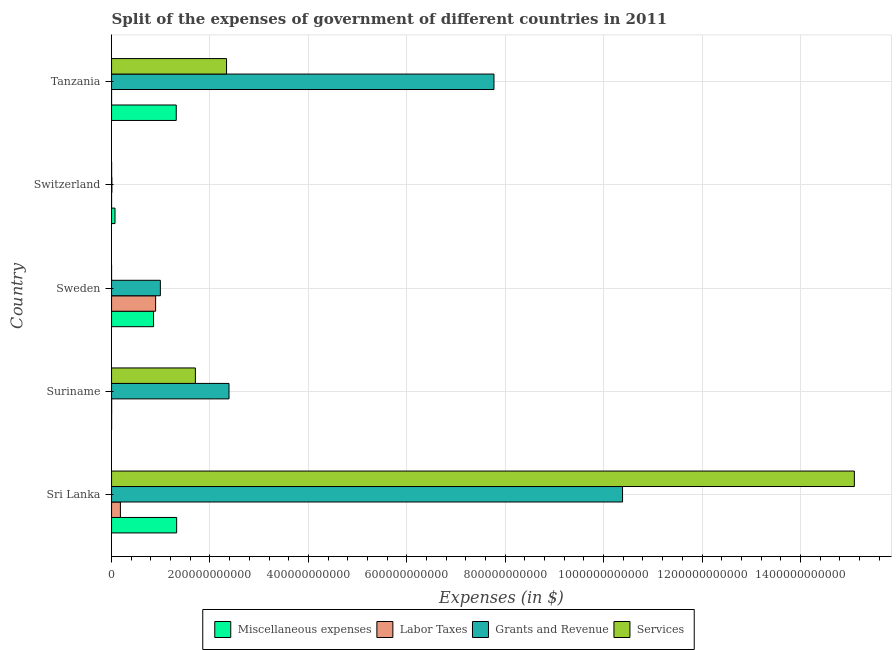How many groups of bars are there?
Your answer should be compact. 5. Are the number of bars per tick equal to the number of legend labels?
Keep it short and to the point. Yes. How many bars are there on the 5th tick from the bottom?
Keep it short and to the point. 4. What is the label of the 1st group of bars from the top?
Offer a terse response. Tanzania. In how many cases, is the number of bars for a given country not equal to the number of legend labels?
Provide a short and direct response. 0. What is the amount spent on grants and revenue in Sweden?
Your response must be concise. 9.92e+1. Across all countries, what is the maximum amount spent on labor taxes?
Your response must be concise. 8.96e+1. Across all countries, what is the minimum amount spent on services?
Ensure brevity in your answer.  1.13e+05. In which country was the amount spent on services maximum?
Provide a short and direct response. Sri Lanka. In which country was the amount spent on grants and revenue minimum?
Your answer should be very brief. Switzerland. What is the total amount spent on services in the graph?
Your answer should be very brief. 1.91e+12. What is the difference between the amount spent on labor taxes in Sweden and that in Tanzania?
Make the answer very short. 8.96e+1. What is the difference between the amount spent on miscellaneous expenses in Sweden and the amount spent on grants and revenue in Switzerland?
Keep it short and to the point. 8.47e+1. What is the average amount spent on grants and revenue per country?
Provide a succinct answer. 4.31e+11. What is the difference between the amount spent on services and amount spent on labor taxes in Tanzania?
Provide a short and direct response. 2.34e+11. What is the ratio of the amount spent on miscellaneous expenses in Sweden to that in Tanzania?
Your answer should be compact. 0.65. Is the amount spent on labor taxes in Switzerland less than that in Tanzania?
Offer a very short reply. No. Is the difference between the amount spent on services in Switzerland and Tanzania greater than the difference between the amount spent on grants and revenue in Switzerland and Tanzania?
Give a very brief answer. Yes. What is the difference between the highest and the second highest amount spent on miscellaneous expenses?
Make the answer very short. 8.34e+08. What is the difference between the highest and the lowest amount spent on grants and revenue?
Your answer should be very brief. 1.04e+12. Is it the case that in every country, the sum of the amount spent on miscellaneous expenses and amount spent on labor taxes is greater than the sum of amount spent on grants and revenue and amount spent on services?
Provide a succinct answer. No. What does the 1st bar from the top in Sri Lanka represents?
Offer a very short reply. Services. What does the 2nd bar from the bottom in Sri Lanka represents?
Your answer should be compact. Labor Taxes. How many bars are there?
Make the answer very short. 20. What is the difference between two consecutive major ticks on the X-axis?
Keep it short and to the point. 2.00e+11. Does the graph contain grids?
Offer a terse response. Yes. How are the legend labels stacked?
Offer a terse response. Horizontal. What is the title of the graph?
Offer a terse response. Split of the expenses of government of different countries in 2011. What is the label or title of the X-axis?
Ensure brevity in your answer.  Expenses (in $). What is the Expenses (in $) of Miscellaneous expenses in Sri Lanka?
Your answer should be very brief. 1.32e+11. What is the Expenses (in $) in Labor Taxes in Sri Lanka?
Provide a short and direct response. 1.80e+1. What is the Expenses (in $) in Grants and Revenue in Sri Lanka?
Provide a short and direct response. 1.04e+12. What is the Expenses (in $) of Services in Sri Lanka?
Keep it short and to the point. 1.51e+12. What is the Expenses (in $) in Miscellaneous expenses in Suriname?
Provide a succinct answer. 1.15e+08. What is the Expenses (in $) in Labor Taxes in Suriname?
Offer a very short reply. 2.01e+08. What is the Expenses (in $) of Grants and Revenue in Suriname?
Provide a succinct answer. 2.39e+11. What is the Expenses (in $) in Services in Suriname?
Your answer should be very brief. 1.70e+11. What is the Expenses (in $) in Miscellaneous expenses in Sweden?
Your answer should be very brief. 8.53e+1. What is the Expenses (in $) of Labor Taxes in Sweden?
Provide a short and direct response. 8.96e+1. What is the Expenses (in $) of Grants and Revenue in Sweden?
Your answer should be very brief. 9.92e+1. What is the Expenses (in $) in Services in Sweden?
Ensure brevity in your answer.  1.13e+05. What is the Expenses (in $) of Miscellaneous expenses in Switzerland?
Ensure brevity in your answer.  6.99e+09. What is the Expenses (in $) of Labor Taxes in Switzerland?
Give a very brief answer. 8.80e+06. What is the Expenses (in $) in Grants and Revenue in Switzerland?
Your answer should be compact. 6.70e+08. What is the Expenses (in $) in Services in Switzerland?
Your answer should be very brief. 1.39e+08. What is the Expenses (in $) in Miscellaneous expenses in Tanzania?
Give a very brief answer. 1.31e+11. What is the Expenses (in $) of Grants and Revenue in Tanzania?
Keep it short and to the point. 7.77e+11. What is the Expenses (in $) of Services in Tanzania?
Make the answer very short. 2.34e+11. Across all countries, what is the maximum Expenses (in $) in Miscellaneous expenses?
Give a very brief answer. 1.32e+11. Across all countries, what is the maximum Expenses (in $) in Labor Taxes?
Provide a succinct answer. 8.96e+1. Across all countries, what is the maximum Expenses (in $) in Grants and Revenue?
Give a very brief answer. 1.04e+12. Across all countries, what is the maximum Expenses (in $) in Services?
Offer a terse response. 1.51e+12. Across all countries, what is the minimum Expenses (in $) in Miscellaneous expenses?
Provide a short and direct response. 1.15e+08. Across all countries, what is the minimum Expenses (in $) in Grants and Revenue?
Your response must be concise. 6.70e+08. Across all countries, what is the minimum Expenses (in $) in Services?
Your answer should be compact. 1.13e+05. What is the total Expenses (in $) of Miscellaneous expenses in the graph?
Your response must be concise. 3.56e+11. What is the total Expenses (in $) in Labor Taxes in the graph?
Your response must be concise. 1.08e+11. What is the total Expenses (in $) of Grants and Revenue in the graph?
Provide a succinct answer. 2.15e+12. What is the total Expenses (in $) of Services in the graph?
Your answer should be very brief. 1.91e+12. What is the difference between the Expenses (in $) of Miscellaneous expenses in Sri Lanka and that in Suriname?
Offer a very short reply. 1.32e+11. What is the difference between the Expenses (in $) in Labor Taxes in Sri Lanka and that in Suriname?
Your answer should be very brief. 1.78e+1. What is the difference between the Expenses (in $) of Grants and Revenue in Sri Lanka and that in Suriname?
Provide a succinct answer. 8.00e+11. What is the difference between the Expenses (in $) of Services in Sri Lanka and that in Suriname?
Provide a short and direct response. 1.34e+12. What is the difference between the Expenses (in $) of Miscellaneous expenses in Sri Lanka and that in Sweden?
Ensure brevity in your answer.  4.70e+1. What is the difference between the Expenses (in $) of Labor Taxes in Sri Lanka and that in Sweden?
Offer a terse response. -7.16e+1. What is the difference between the Expenses (in $) in Grants and Revenue in Sri Lanka and that in Sweden?
Keep it short and to the point. 9.39e+11. What is the difference between the Expenses (in $) in Services in Sri Lanka and that in Sweden?
Make the answer very short. 1.51e+12. What is the difference between the Expenses (in $) of Miscellaneous expenses in Sri Lanka and that in Switzerland?
Keep it short and to the point. 1.25e+11. What is the difference between the Expenses (in $) in Labor Taxes in Sri Lanka and that in Switzerland?
Your answer should be compact. 1.80e+1. What is the difference between the Expenses (in $) in Grants and Revenue in Sri Lanka and that in Switzerland?
Your answer should be very brief. 1.04e+12. What is the difference between the Expenses (in $) of Services in Sri Lanka and that in Switzerland?
Ensure brevity in your answer.  1.51e+12. What is the difference between the Expenses (in $) in Miscellaneous expenses in Sri Lanka and that in Tanzania?
Ensure brevity in your answer.  8.34e+08. What is the difference between the Expenses (in $) of Labor Taxes in Sri Lanka and that in Tanzania?
Offer a terse response. 1.80e+1. What is the difference between the Expenses (in $) in Grants and Revenue in Sri Lanka and that in Tanzania?
Your response must be concise. 2.61e+11. What is the difference between the Expenses (in $) in Services in Sri Lanka and that in Tanzania?
Provide a succinct answer. 1.28e+12. What is the difference between the Expenses (in $) in Miscellaneous expenses in Suriname and that in Sweden?
Your response must be concise. -8.52e+1. What is the difference between the Expenses (in $) of Labor Taxes in Suriname and that in Sweden?
Provide a succinct answer. -8.94e+1. What is the difference between the Expenses (in $) of Grants and Revenue in Suriname and that in Sweden?
Offer a terse response. 1.40e+11. What is the difference between the Expenses (in $) in Services in Suriname and that in Sweden?
Offer a terse response. 1.70e+11. What is the difference between the Expenses (in $) of Miscellaneous expenses in Suriname and that in Switzerland?
Make the answer very short. -6.88e+09. What is the difference between the Expenses (in $) in Labor Taxes in Suriname and that in Switzerland?
Provide a succinct answer. 1.92e+08. What is the difference between the Expenses (in $) in Grants and Revenue in Suriname and that in Switzerland?
Provide a short and direct response. 2.38e+11. What is the difference between the Expenses (in $) in Services in Suriname and that in Switzerland?
Your answer should be very brief. 1.70e+11. What is the difference between the Expenses (in $) in Miscellaneous expenses in Suriname and that in Tanzania?
Your response must be concise. -1.31e+11. What is the difference between the Expenses (in $) in Labor Taxes in Suriname and that in Tanzania?
Your answer should be compact. 1.97e+08. What is the difference between the Expenses (in $) in Grants and Revenue in Suriname and that in Tanzania?
Ensure brevity in your answer.  -5.38e+11. What is the difference between the Expenses (in $) of Services in Suriname and that in Tanzania?
Your answer should be very brief. -6.33e+1. What is the difference between the Expenses (in $) in Miscellaneous expenses in Sweden and that in Switzerland?
Your answer should be compact. 7.83e+1. What is the difference between the Expenses (in $) of Labor Taxes in Sweden and that in Switzerland?
Your response must be concise. 8.95e+1. What is the difference between the Expenses (in $) in Grants and Revenue in Sweden and that in Switzerland?
Your answer should be compact. 9.85e+1. What is the difference between the Expenses (in $) in Services in Sweden and that in Switzerland?
Offer a terse response. -1.39e+08. What is the difference between the Expenses (in $) in Miscellaneous expenses in Sweden and that in Tanzania?
Make the answer very short. -4.61e+1. What is the difference between the Expenses (in $) in Labor Taxes in Sweden and that in Tanzania?
Ensure brevity in your answer.  8.96e+1. What is the difference between the Expenses (in $) of Grants and Revenue in Sweden and that in Tanzania?
Provide a succinct answer. -6.78e+11. What is the difference between the Expenses (in $) in Services in Sweden and that in Tanzania?
Ensure brevity in your answer.  -2.34e+11. What is the difference between the Expenses (in $) in Miscellaneous expenses in Switzerland and that in Tanzania?
Provide a short and direct response. -1.24e+11. What is the difference between the Expenses (in $) in Labor Taxes in Switzerland and that in Tanzania?
Give a very brief answer. 4.80e+06. What is the difference between the Expenses (in $) of Grants and Revenue in Switzerland and that in Tanzania?
Give a very brief answer. -7.77e+11. What is the difference between the Expenses (in $) in Services in Switzerland and that in Tanzania?
Make the answer very short. -2.34e+11. What is the difference between the Expenses (in $) in Miscellaneous expenses in Sri Lanka and the Expenses (in $) in Labor Taxes in Suriname?
Provide a succinct answer. 1.32e+11. What is the difference between the Expenses (in $) of Miscellaneous expenses in Sri Lanka and the Expenses (in $) of Grants and Revenue in Suriname?
Your answer should be very brief. -1.06e+11. What is the difference between the Expenses (in $) of Miscellaneous expenses in Sri Lanka and the Expenses (in $) of Services in Suriname?
Ensure brevity in your answer.  -3.81e+1. What is the difference between the Expenses (in $) in Labor Taxes in Sri Lanka and the Expenses (in $) in Grants and Revenue in Suriname?
Keep it short and to the point. -2.21e+11. What is the difference between the Expenses (in $) of Labor Taxes in Sri Lanka and the Expenses (in $) of Services in Suriname?
Your response must be concise. -1.52e+11. What is the difference between the Expenses (in $) of Grants and Revenue in Sri Lanka and the Expenses (in $) of Services in Suriname?
Provide a short and direct response. 8.68e+11. What is the difference between the Expenses (in $) in Miscellaneous expenses in Sri Lanka and the Expenses (in $) in Labor Taxes in Sweden?
Your answer should be compact. 4.27e+1. What is the difference between the Expenses (in $) in Miscellaneous expenses in Sri Lanka and the Expenses (in $) in Grants and Revenue in Sweden?
Offer a terse response. 3.31e+1. What is the difference between the Expenses (in $) in Miscellaneous expenses in Sri Lanka and the Expenses (in $) in Services in Sweden?
Your answer should be compact. 1.32e+11. What is the difference between the Expenses (in $) in Labor Taxes in Sri Lanka and the Expenses (in $) in Grants and Revenue in Sweden?
Ensure brevity in your answer.  -8.12e+1. What is the difference between the Expenses (in $) of Labor Taxes in Sri Lanka and the Expenses (in $) of Services in Sweden?
Offer a very short reply. 1.80e+1. What is the difference between the Expenses (in $) of Grants and Revenue in Sri Lanka and the Expenses (in $) of Services in Sweden?
Give a very brief answer. 1.04e+12. What is the difference between the Expenses (in $) of Miscellaneous expenses in Sri Lanka and the Expenses (in $) of Labor Taxes in Switzerland?
Provide a succinct answer. 1.32e+11. What is the difference between the Expenses (in $) in Miscellaneous expenses in Sri Lanka and the Expenses (in $) in Grants and Revenue in Switzerland?
Give a very brief answer. 1.32e+11. What is the difference between the Expenses (in $) in Miscellaneous expenses in Sri Lanka and the Expenses (in $) in Services in Switzerland?
Your response must be concise. 1.32e+11. What is the difference between the Expenses (in $) in Labor Taxes in Sri Lanka and the Expenses (in $) in Grants and Revenue in Switzerland?
Make the answer very short. 1.73e+1. What is the difference between the Expenses (in $) in Labor Taxes in Sri Lanka and the Expenses (in $) in Services in Switzerland?
Ensure brevity in your answer.  1.79e+1. What is the difference between the Expenses (in $) of Grants and Revenue in Sri Lanka and the Expenses (in $) of Services in Switzerland?
Provide a succinct answer. 1.04e+12. What is the difference between the Expenses (in $) in Miscellaneous expenses in Sri Lanka and the Expenses (in $) in Labor Taxes in Tanzania?
Give a very brief answer. 1.32e+11. What is the difference between the Expenses (in $) in Miscellaneous expenses in Sri Lanka and the Expenses (in $) in Grants and Revenue in Tanzania?
Provide a succinct answer. -6.45e+11. What is the difference between the Expenses (in $) of Miscellaneous expenses in Sri Lanka and the Expenses (in $) of Services in Tanzania?
Keep it short and to the point. -1.01e+11. What is the difference between the Expenses (in $) of Labor Taxes in Sri Lanka and the Expenses (in $) of Grants and Revenue in Tanzania?
Provide a short and direct response. -7.59e+11. What is the difference between the Expenses (in $) in Labor Taxes in Sri Lanka and the Expenses (in $) in Services in Tanzania?
Your answer should be very brief. -2.16e+11. What is the difference between the Expenses (in $) of Grants and Revenue in Sri Lanka and the Expenses (in $) of Services in Tanzania?
Ensure brevity in your answer.  8.05e+11. What is the difference between the Expenses (in $) in Miscellaneous expenses in Suriname and the Expenses (in $) in Labor Taxes in Sweden?
Your answer should be very brief. -8.94e+1. What is the difference between the Expenses (in $) of Miscellaneous expenses in Suriname and the Expenses (in $) of Grants and Revenue in Sweden?
Provide a succinct answer. -9.91e+1. What is the difference between the Expenses (in $) in Miscellaneous expenses in Suriname and the Expenses (in $) in Services in Sweden?
Your answer should be very brief. 1.15e+08. What is the difference between the Expenses (in $) of Labor Taxes in Suriname and the Expenses (in $) of Grants and Revenue in Sweden?
Make the answer very short. -9.90e+1. What is the difference between the Expenses (in $) of Labor Taxes in Suriname and the Expenses (in $) of Services in Sweden?
Offer a terse response. 2.01e+08. What is the difference between the Expenses (in $) in Grants and Revenue in Suriname and the Expenses (in $) in Services in Sweden?
Your response must be concise. 2.39e+11. What is the difference between the Expenses (in $) of Miscellaneous expenses in Suriname and the Expenses (in $) of Labor Taxes in Switzerland?
Provide a succinct answer. 1.07e+08. What is the difference between the Expenses (in $) in Miscellaneous expenses in Suriname and the Expenses (in $) in Grants and Revenue in Switzerland?
Provide a short and direct response. -5.55e+08. What is the difference between the Expenses (in $) of Miscellaneous expenses in Suriname and the Expenses (in $) of Services in Switzerland?
Offer a very short reply. -2.40e+07. What is the difference between the Expenses (in $) of Labor Taxes in Suriname and the Expenses (in $) of Grants and Revenue in Switzerland?
Make the answer very short. -4.69e+08. What is the difference between the Expenses (in $) of Labor Taxes in Suriname and the Expenses (in $) of Services in Switzerland?
Give a very brief answer. 6.16e+07. What is the difference between the Expenses (in $) in Grants and Revenue in Suriname and the Expenses (in $) in Services in Switzerland?
Provide a short and direct response. 2.39e+11. What is the difference between the Expenses (in $) of Miscellaneous expenses in Suriname and the Expenses (in $) of Labor Taxes in Tanzania?
Offer a terse response. 1.11e+08. What is the difference between the Expenses (in $) of Miscellaneous expenses in Suriname and the Expenses (in $) of Grants and Revenue in Tanzania?
Offer a terse response. -7.77e+11. What is the difference between the Expenses (in $) in Miscellaneous expenses in Suriname and the Expenses (in $) in Services in Tanzania?
Provide a succinct answer. -2.34e+11. What is the difference between the Expenses (in $) of Labor Taxes in Suriname and the Expenses (in $) of Grants and Revenue in Tanzania?
Give a very brief answer. -7.77e+11. What is the difference between the Expenses (in $) of Labor Taxes in Suriname and the Expenses (in $) of Services in Tanzania?
Your answer should be compact. -2.33e+11. What is the difference between the Expenses (in $) in Grants and Revenue in Suriname and the Expenses (in $) in Services in Tanzania?
Your answer should be compact. 5.02e+09. What is the difference between the Expenses (in $) of Miscellaneous expenses in Sweden and the Expenses (in $) of Labor Taxes in Switzerland?
Ensure brevity in your answer.  8.53e+1. What is the difference between the Expenses (in $) in Miscellaneous expenses in Sweden and the Expenses (in $) in Grants and Revenue in Switzerland?
Your answer should be compact. 8.47e+1. What is the difference between the Expenses (in $) in Miscellaneous expenses in Sweden and the Expenses (in $) in Services in Switzerland?
Provide a short and direct response. 8.52e+1. What is the difference between the Expenses (in $) in Labor Taxes in Sweden and the Expenses (in $) in Grants and Revenue in Switzerland?
Provide a succinct answer. 8.89e+1. What is the difference between the Expenses (in $) of Labor Taxes in Sweden and the Expenses (in $) of Services in Switzerland?
Your answer should be compact. 8.94e+1. What is the difference between the Expenses (in $) in Grants and Revenue in Sweden and the Expenses (in $) in Services in Switzerland?
Ensure brevity in your answer.  9.90e+1. What is the difference between the Expenses (in $) in Miscellaneous expenses in Sweden and the Expenses (in $) in Labor Taxes in Tanzania?
Your answer should be very brief. 8.53e+1. What is the difference between the Expenses (in $) of Miscellaneous expenses in Sweden and the Expenses (in $) of Grants and Revenue in Tanzania?
Your answer should be very brief. -6.92e+11. What is the difference between the Expenses (in $) in Miscellaneous expenses in Sweden and the Expenses (in $) in Services in Tanzania?
Your answer should be compact. -1.48e+11. What is the difference between the Expenses (in $) of Labor Taxes in Sweden and the Expenses (in $) of Grants and Revenue in Tanzania?
Offer a terse response. -6.88e+11. What is the difference between the Expenses (in $) of Labor Taxes in Sweden and the Expenses (in $) of Services in Tanzania?
Make the answer very short. -1.44e+11. What is the difference between the Expenses (in $) in Grants and Revenue in Sweden and the Expenses (in $) in Services in Tanzania?
Your answer should be very brief. -1.35e+11. What is the difference between the Expenses (in $) of Miscellaneous expenses in Switzerland and the Expenses (in $) of Labor Taxes in Tanzania?
Provide a short and direct response. 6.99e+09. What is the difference between the Expenses (in $) in Miscellaneous expenses in Switzerland and the Expenses (in $) in Grants and Revenue in Tanzania?
Provide a succinct answer. -7.70e+11. What is the difference between the Expenses (in $) in Miscellaneous expenses in Switzerland and the Expenses (in $) in Services in Tanzania?
Offer a terse response. -2.27e+11. What is the difference between the Expenses (in $) in Labor Taxes in Switzerland and the Expenses (in $) in Grants and Revenue in Tanzania?
Provide a succinct answer. -7.77e+11. What is the difference between the Expenses (in $) of Labor Taxes in Switzerland and the Expenses (in $) of Services in Tanzania?
Provide a succinct answer. -2.34e+11. What is the difference between the Expenses (in $) in Grants and Revenue in Switzerland and the Expenses (in $) in Services in Tanzania?
Keep it short and to the point. -2.33e+11. What is the average Expenses (in $) in Miscellaneous expenses per country?
Your answer should be very brief. 7.12e+1. What is the average Expenses (in $) of Labor Taxes per country?
Provide a succinct answer. 2.16e+1. What is the average Expenses (in $) of Grants and Revenue per country?
Provide a succinct answer. 4.31e+11. What is the average Expenses (in $) of Services per country?
Provide a succinct answer. 3.83e+11. What is the difference between the Expenses (in $) of Miscellaneous expenses and Expenses (in $) of Labor Taxes in Sri Lanka?
Offer a very short reply. 1.14e+11. What is the difference between the Expenses (in $) of Miscellaneous expenses and Expenses (in $) of Grants and Revenue in Sri Lanka?
Your answer should be compact. -9.06e+11. What is the difference between the Expenses (in $) in Miscellaneous expenses and Expenses (in $) in Services in Sri Lanka?
Your answer should be compact. -1.38e+12. What is the difference between the Expenses (in $) of Labor Taxes and Expenses (in $) of Grants and Revenue in Sri Lanka?
Ensure brevity in your answer.  -1.02e+12. What is the difference between the Expenses (in $) of Labor Taxes and Expenses (in $) of Services in Sri Lanka?
Your answer should be very brief. -1.49e+12. What is the difference between the Expenses (in $) in Grants and Revenue and Expenses (in $) in Services in Sri Lanka?
Keep it short and to the point. -4.71e+11. What is the difference between the Expenses (in $) in Miscellaneous expenses and Expenses (in $) in Labor Taxes in Suriname?
Offer a very short reply. -8.56e+07. What is the difference between the Expenses (in $) in Miscellaneous expenses and Expenses (in $) in Grants and Revenue in Suriname?
Provide a short and direct response. -2.39e+11. What is the difference between the Expenses (in $) in Miscellaneous expenses and Expenses (in $) in Services in Suriname?
Give a very brief answer. -1.70e+11. What is the difference between the Expenses (in $) of Labor Taxes and Expenses (in $) of Grants and Revenue in Suriname?
Your response must be concise. -2.38e+11. What is the difference between the Expenses (in $) of Labor Taxes and Expenses (in $) of Services in Suriname?
Give a very brief answer. -1.70e+11. What is the difference between the Expenses (in $) of Grants and Revenue and Expenses (in $) of Services in Suriname?
Your response must be concise. 6.83e+1. What is the difference between the Expenses (in $) of Miscellaneous expenses and Expenses (in $) of Labor Taxes in Sweden?
Give a very brief answer. -4.24e+09. What is the difference between the Expenses (in $) of Miscellaneous expenses and Expenses (in $) of Grants and Revenue in Sweden?
Offer a terse response. -1.39e+1. What is the difference between the Expenses (in $) in Miscellaneous expenses and Expenses (in $) in Services in Sweden?
Offer a very short reply. 8.53e+1. What is the difference between the Expenses (in $) in Labor Taxes and Expenses (in $) in Grants and Revenue in Sweden?
Offer a terse response. -9.62e+09. What is the difference between the Expenses (in $) in Labor Taxes and Expenses (in $) in Services in Sweden?
Your answer should be very brief. 8.96e+1. What is the difference between the Expenses (in $) in Grants and Revenue and Expenses (in $) in Services in Sweden?
Your answer should be very brief. 9.92e+1. What is the difference between the Expenses (in $) in Miscellaneous expenses and Expenses (in $) in Labor Taxes in Switzerland?
Provide a short and direct response. 6.98e+09. What is the difference between the Expenses (in $) in Miscellaneous expenses and Expenses (in $) in Grants and Revenue in Switzerland?
Offer a very short reply. 6.32e+09. What is the difference between the Expenses (in $) of Miscellaneous expenses and Expenses (in $) of Services in Switzerland?
Your response must be concise. 6.85e+09. What is the difference between the Expenses (in $) of Labor Taxes and Expenses (in $) of Grants and Revenue in Switzerland?
Your answer should be compact. -6.61e+08. What is the difference between the Expenses (in $) in Labor Taxes and Expenses (in $) in Services in Switzerland?
Give a very brief answer. -1.31e+08. What is the difference between the Expenses (in $) of Grants and Revenue and Expenses (in $) of Services in Switzerland?
Provide a succinct answer. 5.31e+08. What is the difference between the Expenses (in $) of Miscellaneous expenses and Expenses (in $) of Labor Taxes in Tanzania?
Keep it short and to the point. 1.31e+11. What is the difference between the Expenses (in $) of Miscellaneous expenses and Expenses (in $) of Grants and Revenue in Tanzania?
Make the answer very short. -6.46e+11. What is the difference between the Expenses (in $) in Miscellaneous expenses and Expenses (in $) in Services in Tanzania?
Offer a terse response. -1.02e+11. What is the difference between the Expenses (in $) of Labor Taxes and Expenses (in $) of Grants and Revenue in Tanzania?
Provide a short and direct response. -7.77e+11. What is the difference between the Expenses (in $) in Labor Taxes and Expenses (in $) in Services in Tanzania?
Your answer should be compact. -2.34e+11. What is the difference between the Expenses (in $) of Grants and Revenue and Expenses (in $) of Services in Tanzania?
Provide a succinct answer. 5.43e+11. What is the ratio of the Expenses (in $) in Miscellaneous expenses in Sri Lanka to that in Suriname?
Give a very brief answer. 1146.67. What is the ratio of the Expenses (in $) of Labor Taxes in Sri Lanka to that in Suriname?
Provide a succinct answer. 89.53. What is the ratio of the Expenses (in $) in Grants and Revenue in Sri Lanka to that in Suriname?
Offer a terse response. 4.35. What is the ratio of the Expenses (in $) of Services in Sri Lanka to that in Suriname?
Provide a short and direct response. 8.86. What is the ratio of the Expenses (in $) in Miscellaneous expenses in Sri Lanka to that in Sweden?
Your answer should be very brief. 1.55. What is the ratio of the Expenses (in $) in Labor Taxes in Sri Lanka to that in Sweden?
Your answer should be very brief. 0.2. What is the ratio of the Expenses (in $) of Grants and Revenue in Sri Lanka to that in Sweden?
Give a very brief answer. 10.47. What is the ratio of the Expenses (in $) of Services in Sri Lanka to that in Sweden?
Your response must be concise. 1.34e+07. What is the ratio of the Expenses (in $) of Miscellaneous expenses in Sri Lanka to that in Switzerland?
Offer a terse response. 18.92. What is the ratio of the Expenses (in $) of Labor Taxes in Sri Lanka to that in Switzerland?
Your response must be concise. 2044.9. What is the ratio of the Expenses (in $) in Grants and Revenue in Sri Lanka to that in Switzerland?
Give a very brief answer. 1550.06. What is the ratio of the Expenses (in $) in Services in Sri Lanka to that in Switzerland?
Provide a succinct answer. 1.08e+04. What is the ratio of the Expenses (in $) of Miscellaneous expenses in Sri Lanka to that in Tanzania?
Provide a succinct answer. 1.01. What is the ratio of the Expenses (in $) of Labor Taxes in Sri Lanka to that in Tanzania?
Your answer should be very brief. 4498.79. What is the ratio of the Expenses (in $) in Grants and Revenue in Sri Lanka to that in Tanzania?
Provide a succinct answer. 1.34. What is the ratio of the Expenses (in $) of Services in Sri Lanka to that in Tanzania?
Give a very brief answer. 6.46. What is the ratio of the Expenses (in $) of Miscellaneous expenses in Suriname to that in Sweden?
Your answer should be compact. 0. What is the ratio of the Expenses (in $) of Labor Taxes in Suriname to that in Sweden?
Provide a short and direct response. 0. What is the ratio of the Expenses (in $) in Grants and Revenue in Suriname to that in Sweden?
Your response must be concise. 2.41. What is the ratio of the Expenses (in $) of Services in Suriname to that in Sweden?
Your answer should be very brief. 1.51e+06. What is the ratio of the Expenses (in $) in Miscellaneous expenses in Suriname to that in Switzerland?
Your answer should be very brief. 0.02. What is the ratio of the Expenses (in $) in Labor Taxes in Suriname to that in Switzerland?
Offer a very short reply. 22.84. What is the ratio of the Expenses (in $) of Grants and Revenue in Suriname to that in Switzerland?
Keep it short and to the point. 356.28. What is the ratio of the Expenses (in $) of Services in Suriname to that in Switzerland?
Offer a terse response. 1222.25. What is the ratio of the Expenses (in $) in Miscellaneous expenses in Suriname to that in Tanzania?
Your answer should be compact. 0. What is the ratio of the Expenses (in $) of Labor Taxes in Suriname to that in Tanzania?
Your answer should be very brief. 50.25. What is the ratio of the Expenses (in $) in Grants and Revenue in Suriname to that in Tanzania?
Provide a short and direct response. 0.31. What is the ratio of the Expenses (in $) of Services in Suriname to that in Tanzania?
Your answer should be compact. 0.73. What is the ratio of the Expenses (in $) in Miscellaneous expenses in Sweden to that in Switzerland?
Offer a terse response. 12.2. What is the ratio of the Expenses (in $) in Labor Taxes in Sweden to that in Switzerland?
Ensure brevity in your answer.  1.02e+04. What is the ratio of the Expenses (in $) of Grants and Revenue in Sweden to that in Switzerland?
Provide a short and direct response. 148.03. What is the ratio of the Expenses (in $) in Services in Sweden to that in Switzerland?
Keep it short and to the point. 0. What is the ratio of the Expenses (in $) in Miscellaneous expenses in Sweden to that in Tanzania?
Make the answer very short. 0.65. What is the ratio of the Expenses (in $) in Labor Taxes in Sweden to that in Tanzania?
Your answer should be very brief. 2.24e+04. What is the ratio of the Expenses (in $) of Grants and Revenue in Sweden to that in Tanzania?
Your answer should be very brief. 0.13. What is the ratio of the Expenses (in $) in Services in Sweden to that in Tanzania?
Keep it short and to the point. 0. What is the ratio of the Expenses (in $) of Miscellaneous expenses in Switzerland to that in Tanzania?
Your response must be concise. 0.05. What is the ratio of the Expenses (in $) of Grants and Revenue in Switzerland to that in Tanzania?
Make the answer very short. 0. What is the ratio of the Expenses (in $) of Services in Switzerland to that in Tanzania?
Make the answer very short. 0. What is the difference between the highest and the second highest Expenses (in $) of Miscellaneous expenses?
Offer a terse response. 8.34e+08. What is the difference between the highest and the second highest Expenses (in $) in Labor Taxes?
Make the answer very short. 7.16e+1. What is the difference between the highest and the second highest Expenses (in $) in Grants and Revenue?
Your answer should be very brief. 2.61e+11. What is the difference between the highest and the second highest Expenses (in $) in Services?
Your response must be concise. 1.28e+12. What is the difference between the highest and the lowest Expenses (in $) in Miscellaneous expenses?
Keep it short and to the point. 1.32e+11. What is the difference between the highest and the lowest Expenses (in $) in Labor Taxes?
Your response must be concise. 8.96e+1. What is the difference between the highest and the lowest Expenses (in $) of Grants and Revenue?
Give a very brief answer. 1.04e+12. What is the difference between the highest and the lowest Expenses (in $) of Services?
Ensure brevity in your answer.  1.51e+12. 